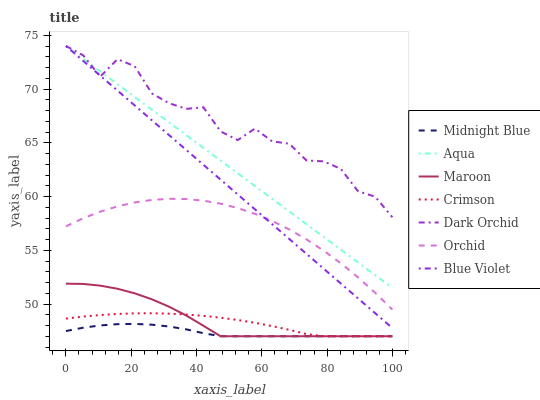Does Aqua have the minimum area under the curve?
Answer yes or no. No. Does Aqua have the maximum area under the curve?
Answer yes or no. No. Is Dark Orchid the smoothest?
Answer yes or no. No. Is Aqua the roughest?
Answer yes or no. No. Does Aqua have the lowest value?
Answer yes or no. No. Does Maroon have the highest value?
Answer yes or no. No. Is Crimson less than Orchid?
Answer yes or no. Yes. Is Aqua greater than Midnight Blue?
Answer yes or no. Yes. Does Crimson intersect Orchid?
Answer yes or no. No. 